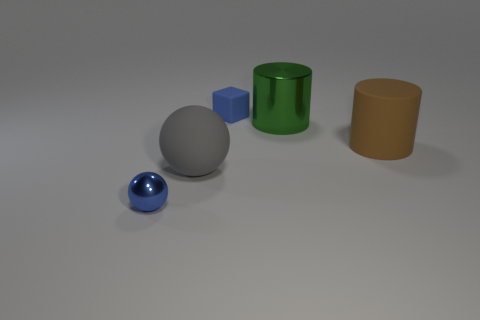What is the size of the thing that is the same color as the tiny cube?
Provide a short and direct response. Small. Does the blue ball have the same material as the big brown thing?
Offer a very short reply. No. What number of metallic things are tiny blocks or tiny red objects?
Ensure brevity in your answer.  0. There is a thing that is the same size as the blue ball; what is its color?
Your answer should be very brief. Blue. How many other large rubber objects are the same shape as the gray rubber object?
Ensure brevity in your answer.  0. What number of balls are tiny blue matte things or big rubber things?
Your response must be concise. 1. Do the matte object that is behind the big green metallic cylinder and the big object left of the green object have the same shape?
Your response must be concise. No. What is the green object made of?
Your response must be concise. Metal. There is another object that is the same color as the tiny rubber object; what shape is it?
Your answer should be compact. Sphere. How many other cylinders have the same size as the brown matte cylinder?
Make the answer very short. 1. 